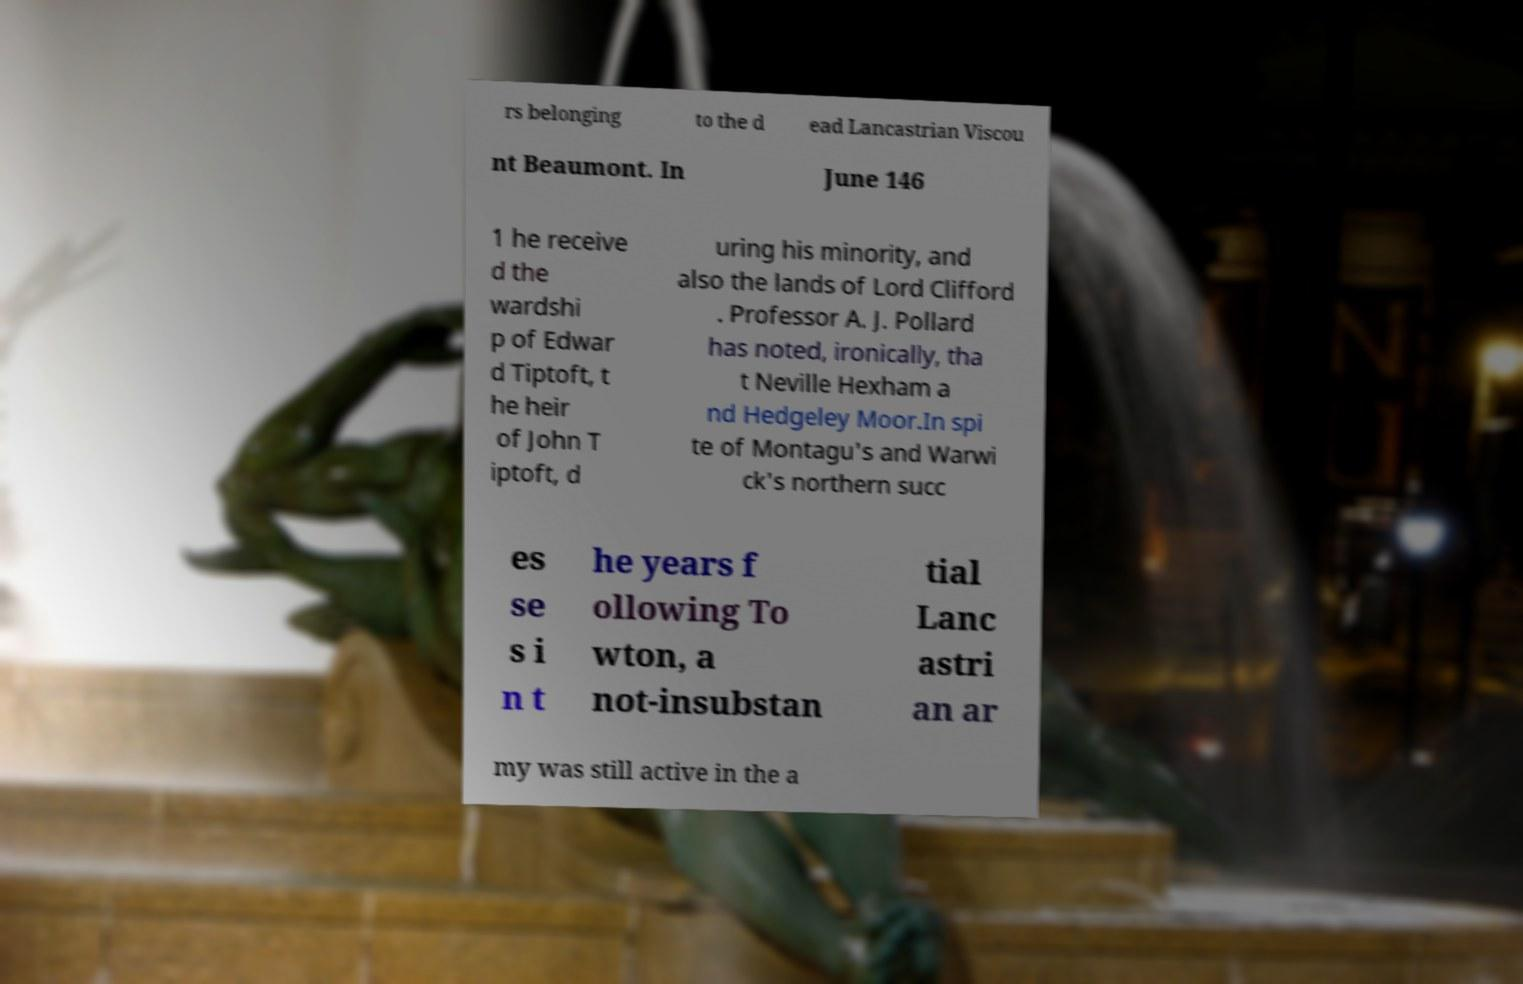There's text embedded in this image that I need extracted. Can you transcribe it verbatim? rs belonging to the d ead Lancastrian Viscou nt Beaumont. In June 146 1 he receive d the wardshi p of Edwar d Tiptoft, t he heir of John T iptoft, d uring his minority, and also the lands of Lord Clifford . Professor A. J. Pollard has noted, ironically, tha t Neville Hexham a nd Hedgeley Moor.In spi te of Montagu's and Warwi ck's northern succ es se s i n t he years f ollowing To wton, a not-insubstan tial Lanc astri an ar my was still active in the a 